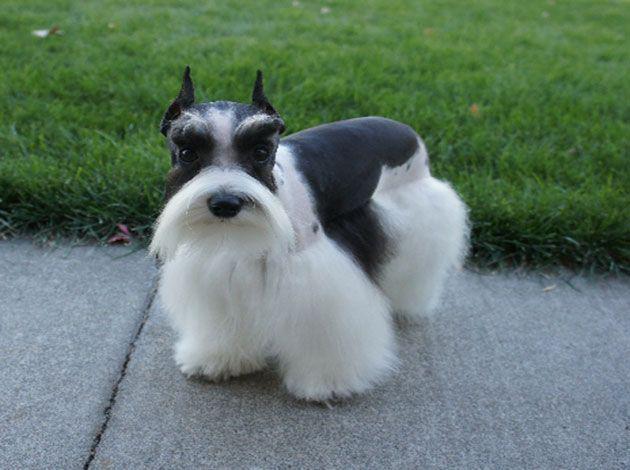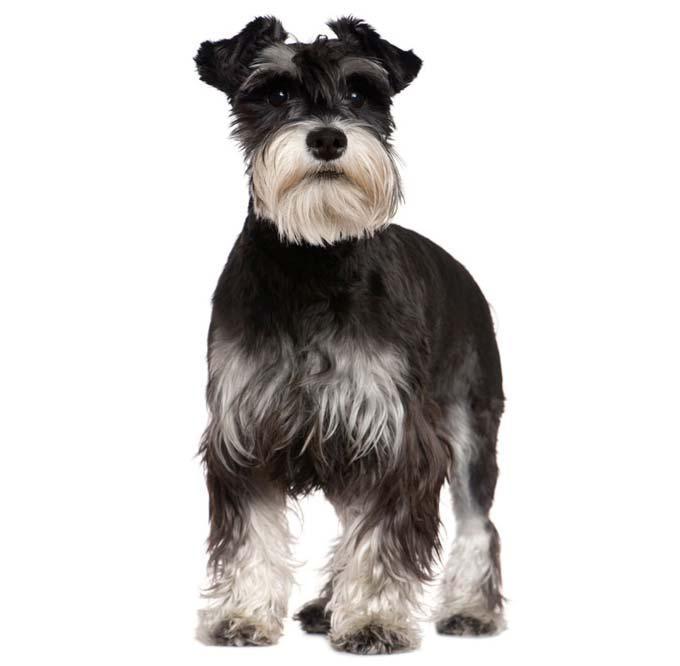The first image is the image on the left, the second image is the image on the right. For the images displayed, is the sentence "There is one image of a mostly black dog and one of at least one gray dog." factually correct? Answer yes or no. No. The first image is the image on the left, the second image is the image on the right. Considering the images on both sides, is "There is grass visible on one of the images." valid? Answer yes or no. Yes. The first image is the image on the left, the second image is the image on the right. Analyze the images presented: Is the assertion "In one image there is a dog outside with some grass in the image." valid? Answer yes or no. Yes. The first image is the image on the left, the second image is the image on the right. For the images displayed, is the sentence "There is an expanse of green grass in one dog image." factually correct? Answer yes or no. Yes. 